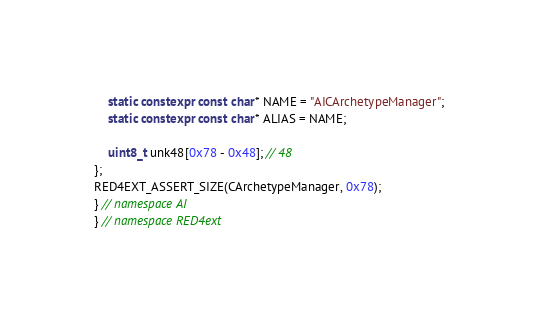<code> <loc_0><loc_0><loc_500><loc_500><_C++_>    static constexpr const char* NAME = "AICArchetypeManager";
    static constexpr const char* ALIAS = NAME;

    uint8_t unk48[0x78 - 0x48]; // 48
};
RED4EXT_ASSERT_SIZE(CArchetypeManager, 0x78);
} // namespace AI
} // namespace RED4ext
</code> 